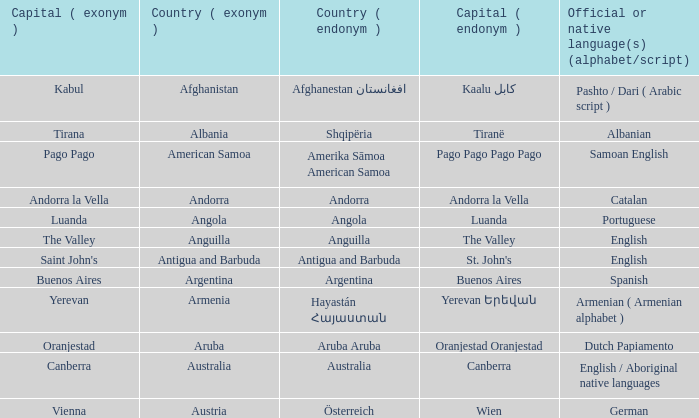What is the local name given to the city of Canberra? Canberra. 